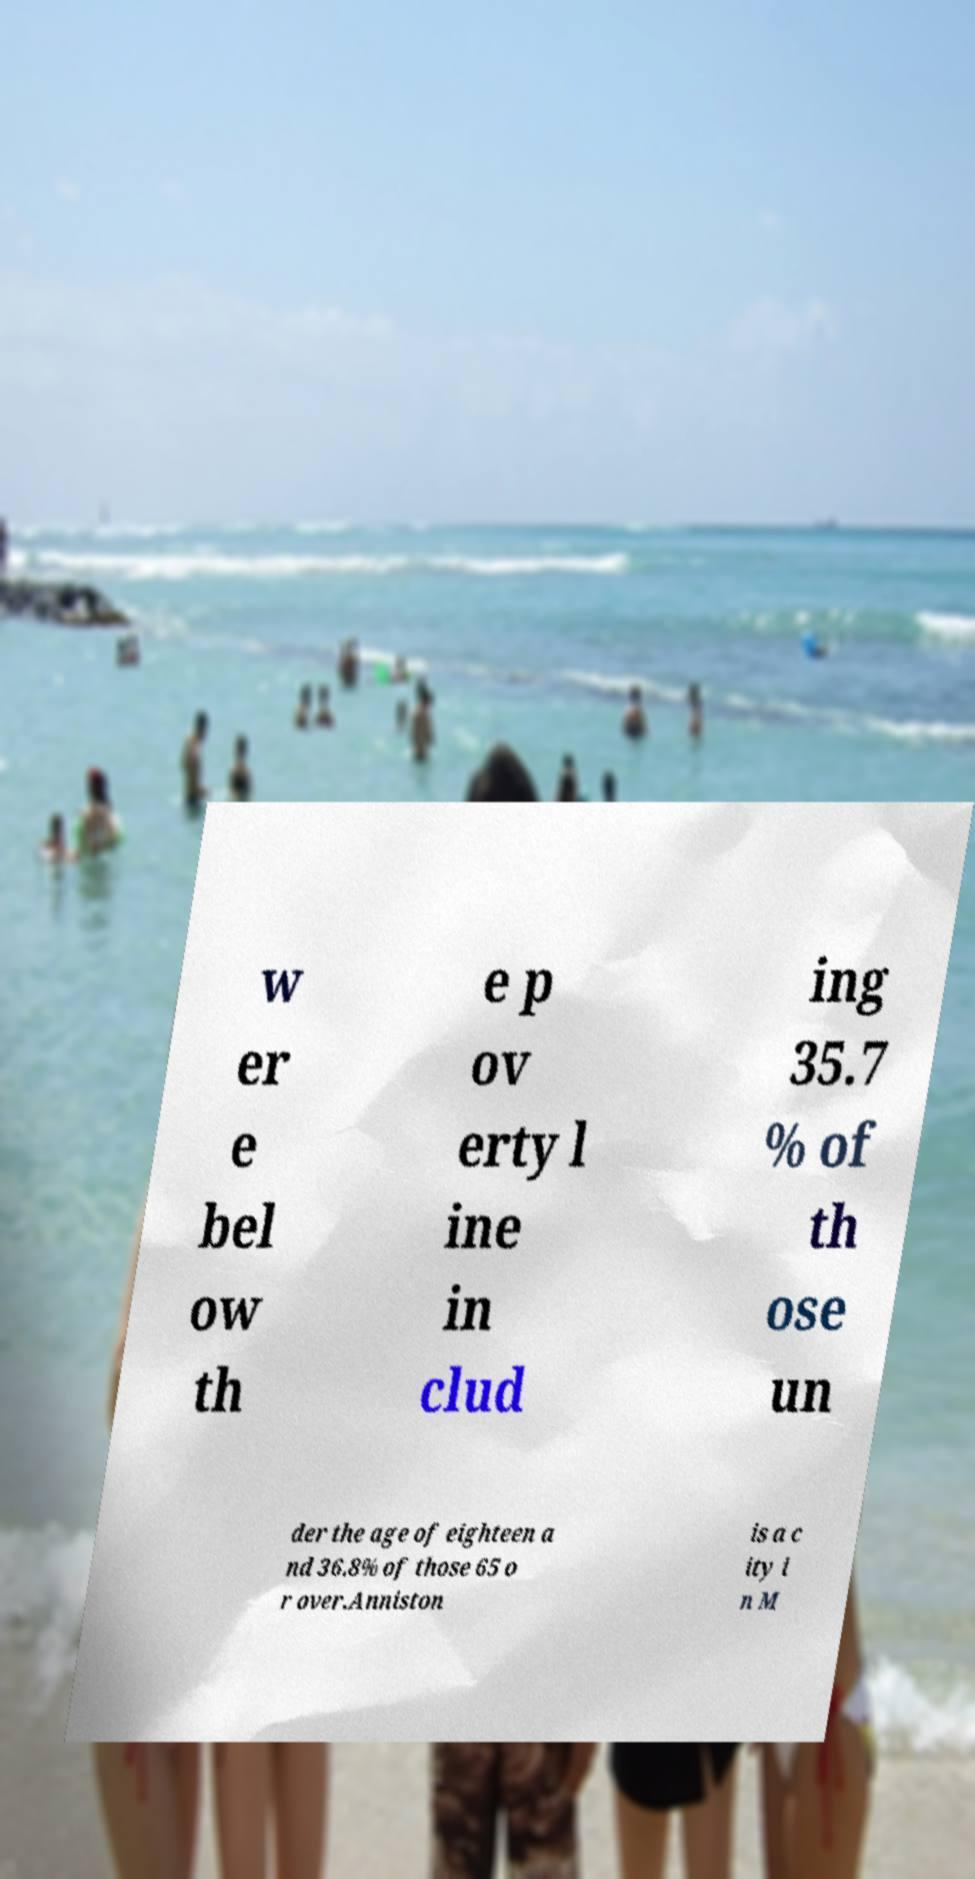For documentation purposes, I need the text within this image transcribed. Could you provide that? w er e bel ow th e p ov erty l ine in clud ing 35.7 % of th ose un der the age of eighteen a nd 36.8% of those 65 o r over.Anniston is a c ity i n M 